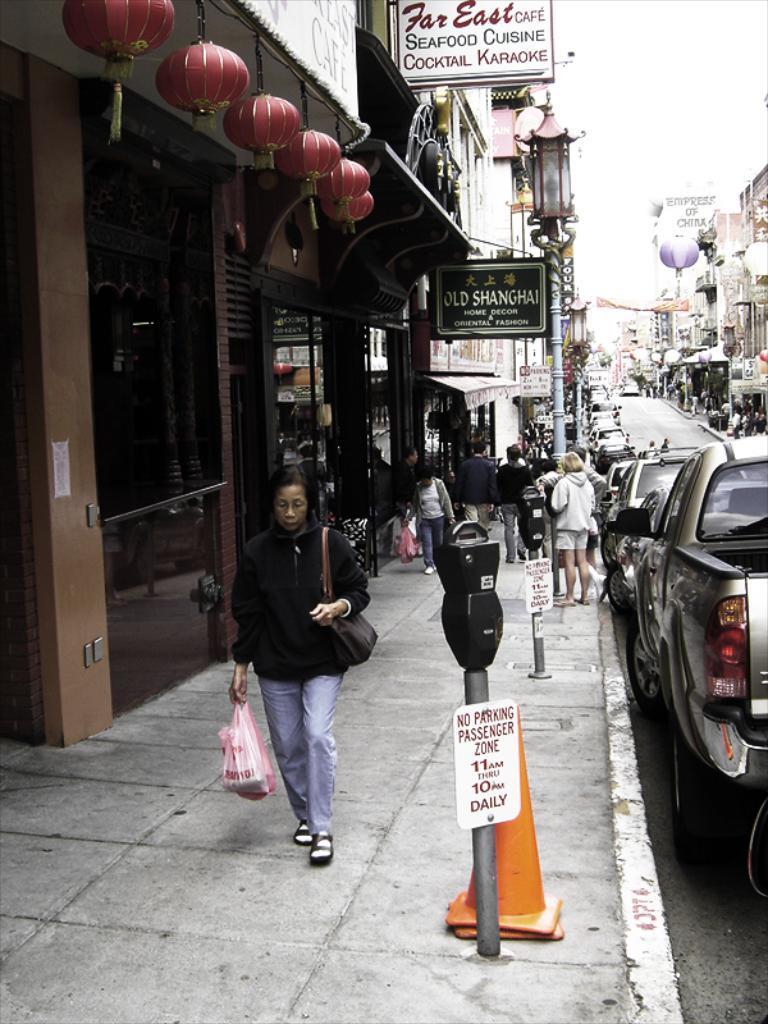Describe this image in one or two sentences. In this image we can see people are walking on the sidewalk. Here we can see car parking ticket machine, traffic cones, cars parked here, buildings, boards, light poles and sky in the background. 